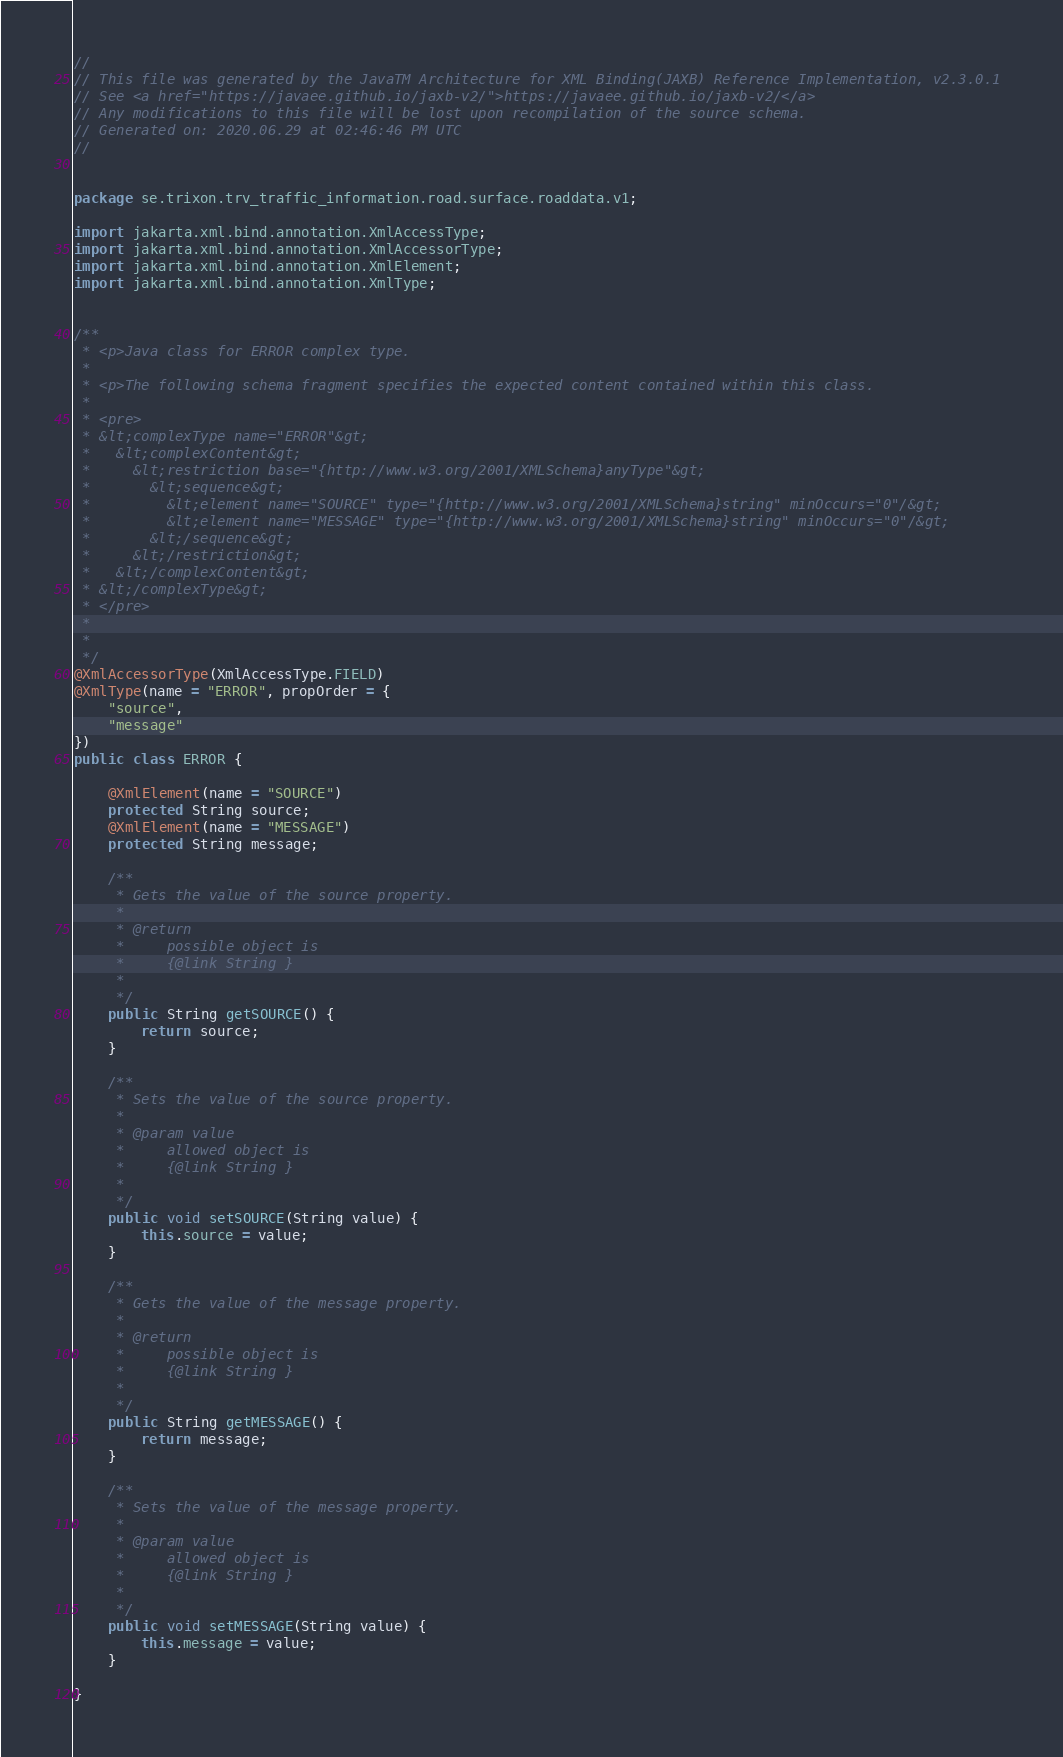<code> <loc_0><loc_0><loc_500><loc_500><_Java_>//
// This file was generated by the JavaTM Architecture for XML Binding(JAXB) Reference Implementation, v2.3.0.1 
// See <a href="https://javaee.github.io/jaxb-v2/">https://javaee.github.io/jaxb-v2/</a> 
// Any modifications to this file will be lost upon recompilation of the source schema. 
// Generated on: 2020.06.29 at 02:46:46 PM UTC 
//


package se.trixon.trv_traffic_information.road.surface.roaddata.v1;

import jakarta.xml.bind.annotation.XmlAccessType;
import jakarta.xml.bind.annotation.XmlAccessorType;
import jakarta.xml.bind.annotation.XmlElement;
import jakarta.xml.bind.annotation.XmlType;


/**
 * <p>Java class for ERROR complex type.
 * 
 * <p>The following schema fragment specifies the expected content contained within this class.
 * 
 * <pre>
 * &lt;complexType name="ERROR"&gt;
 *   &lt;complexContent&gt;
 *     &lt;restriction base="{http://www.w3.org/2001/XMLSchema}anyType"&gt;
 *       &lt;sequence&gt;
 *         &lt;element name="SOURCE" type="{http://www.w3.org/2001/XMLSchema}string" minOccurs="0"/&gt;
 *         &lt;element name="MESSAGE" type="{http://www.w3.org/2001/XMLSchema}string" minOccurs="0"/&gt;
 *       &lt;/sequence&gt;
 *     &lt;/restriction&gt;
 *   &lt;/complexContent&gt;
 * &lt;/complexType&gt;
 * </pre>
 * 
 * 
 */
@XmlAccessorType(XmlAccessType.FIELD)
@XmlType(name = "ERROR", propOrder = {
    "source",
    "message"
})
public class ERROR {

    @XmlElement(name = "SOURCE")
    protected String source;
    @XmlElement(name = "MESSAGE")
    protected String message;

    /**
     * Gets the value of the source property.
     * 
     * @return
     *     possible object is
     *     {@link String }
     *     
     */
    public String getSOURCE() {
        return source;
    }

    /**
     * Sets the value of the source property.
     * 
     * @param value
     *     allowed object is
     *     {@link String }
     *     
     */
    public void setSOURCE(String value) {
        this.source = value;
    }

    /**
     * Gets the value of the message property.
     * 
     * @return
     *     possible object is
     *     {@link String }
     *     
     */
    public String getMESSAGE() {
        return message;
    }

    /**
     * Sets the value of the message property.
     * 
     * @param value
     *     allowed object is
     *     {@link String }
     *     
     */
    public void setMESSAGE(String value) {
        this.message = value;
    }

}
</code> 